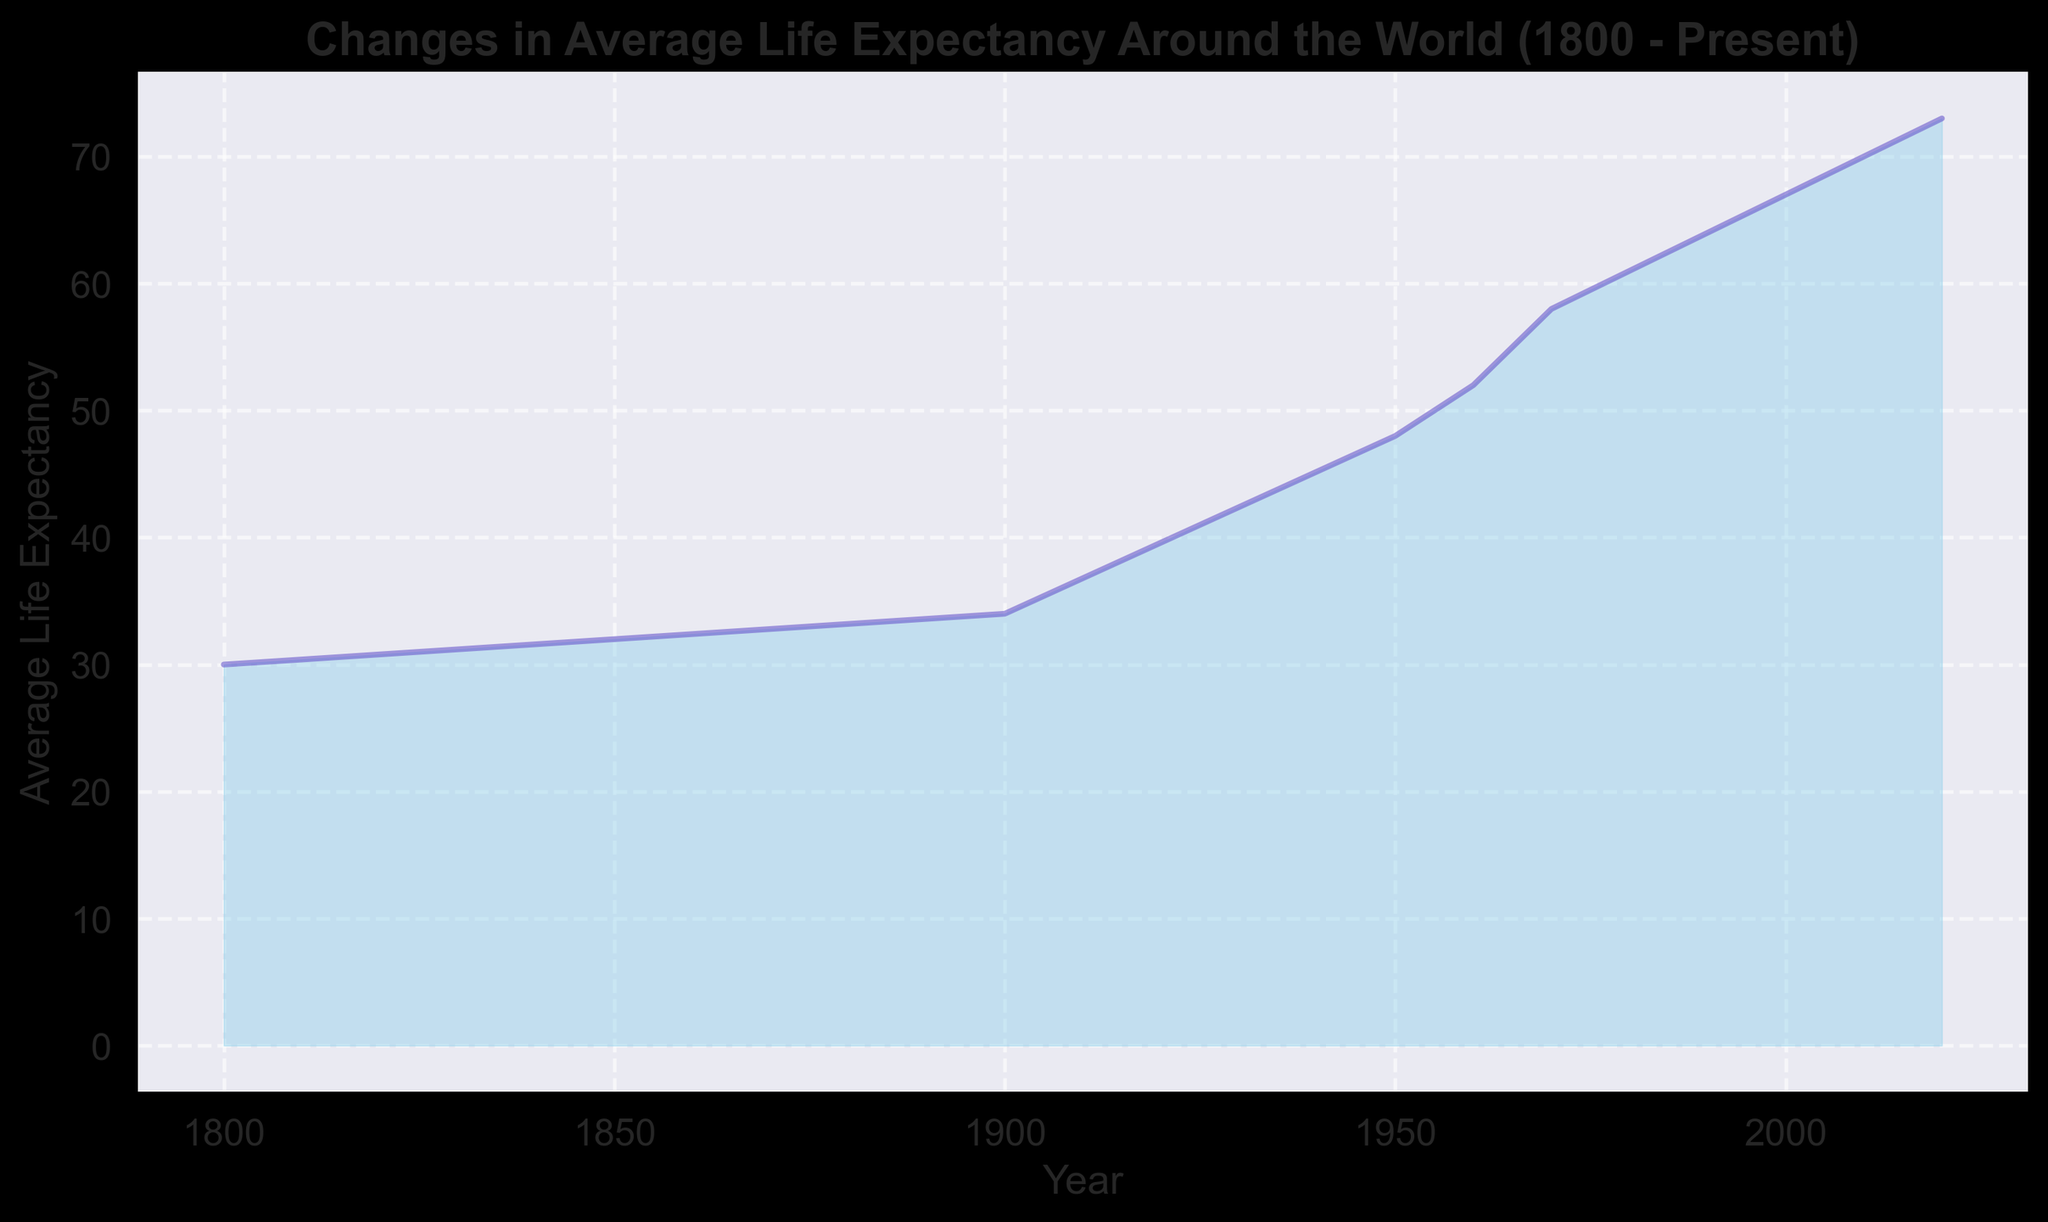What is the average life expectancy in the year 1925? The data point for the year 1925 shows an average life expectancy denoted by the corresponding height of the filled area on the chart. Trace this point vertically to read the exact value.
Answer: 41 How much did the global average life expectancy increase between the years 1900 and 1925? Subtract the average life expectancy in 1900 from that in 1925: 41 - 34.
Answer: 7 Compare the average life expectancy in the years 1800 and 2020. Which one is greater and by how much? Subtract the average life expectancy in 1800 from that in 2020: 73 - 30. Clearly, 2020 has a higher value.
Answer: 43 What is the average life expectancy trend in the 20th century (1900 - 2000)? Observe the slope of the line from 1900 to 2000. The line steadily rises, indicating an increase in average life expectancy.
Answer: Increasing By what percentage did the global average life expectancy increase from 1950 to 2000? Calculate the percentage increase using the formula: [(67 - 48) / 48] * 100 = 39.58%
Answer: 39.58% Identify the period with the steepest increase in average life expectancy. When did this occur and what might this indicate historically? Look for the segment with the steepest slope. The period between 1950 and 1960 shows the largest rise, indicating rapid advancements in medical science post-World War II.
Answer: 1950-1960 How does the visual representation of the average life expectancy change from 19th century to present? The filled area chart shows a gradual rise initially, followed by a steeper increase in the 20th century, indicating improved health conditions and advancements in medical treatments.
Answer: Gradual increase, then steeper rise Compare the growth rate of average life expectancy between 1800-1900 and 1900-2000. Which period shows a higher growth rate? Calculate the differences for each period: 34-30 = 4 for 1800-1900, and 67-34 = 33 for 1900-2000. The second period has a higher growth rate.
Answer: 1900-2000 What is the relationship between the height of the filled area and the data values represented in the chart? The height of the filled area corresponds proportionally to the average life expectancy values indicated on the y-axis, with higher values having taller heights.
Answer: Proportional 